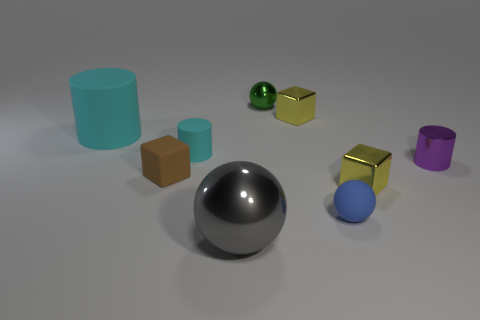Add 1 matte spheres. How many objects exist? 10 Subtract all cylinders. How many objects are left? 6 Subtract 0 cyan balls. How many objects are left? 9 Subtract all small balls. Subtract all gray shiny balls. How many objects are left? 6 Add 2 tiny purple cylinders. How many tiny purple cylinders are left? 3 Add 5 large cyan matte cylinders. How many large cyan matte cylinders exist? 6 